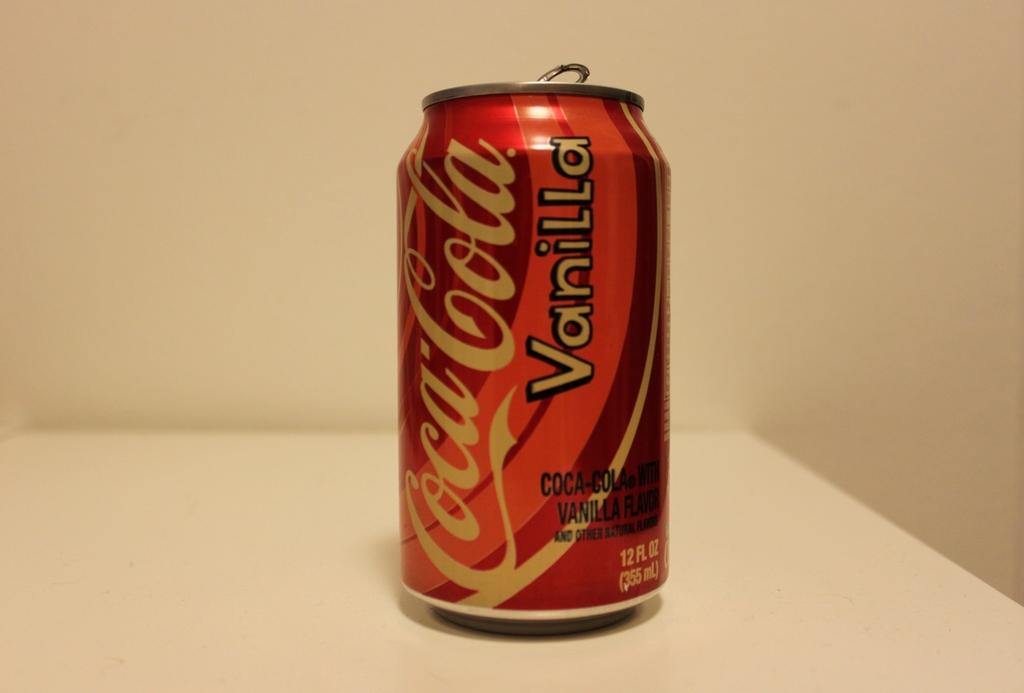What flavor is the drink ?
Give a very brief answer. Vanilla. What brand of drink is this?
Your answer should be compact. Coca-cola. 